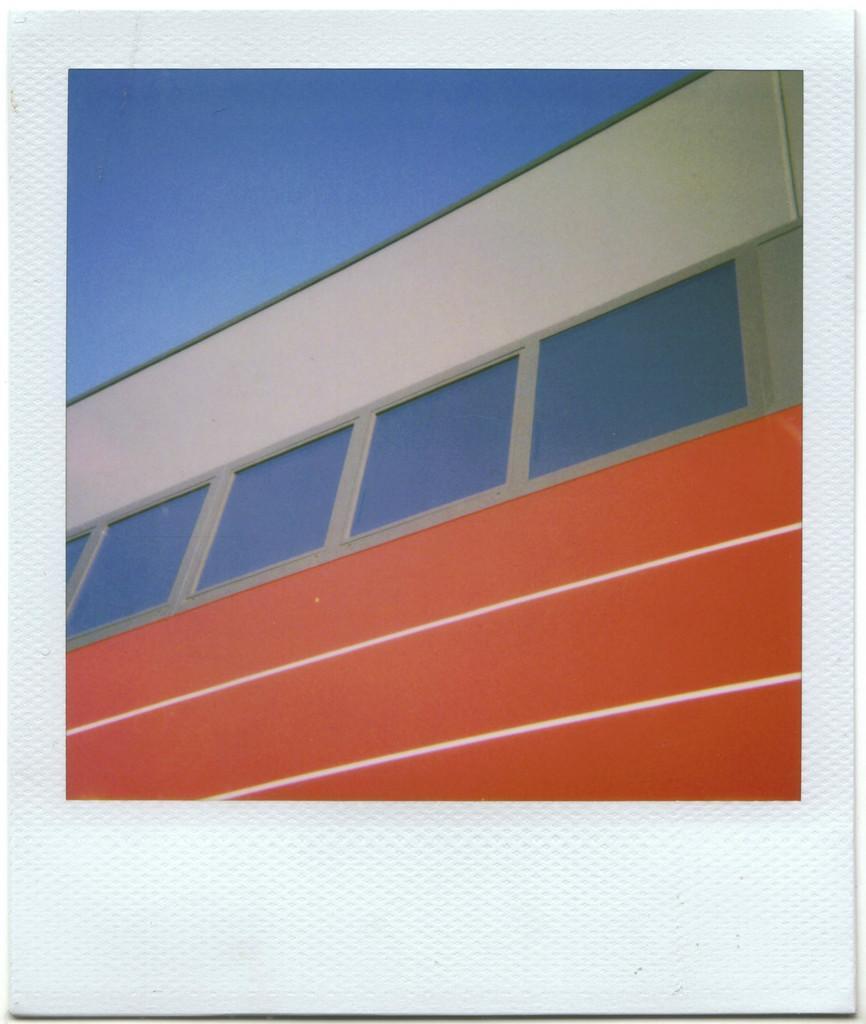Please provide a concise description of this image. In this picture, there is a tissue paper. On the tissue paper, there is another picture of a wall. 